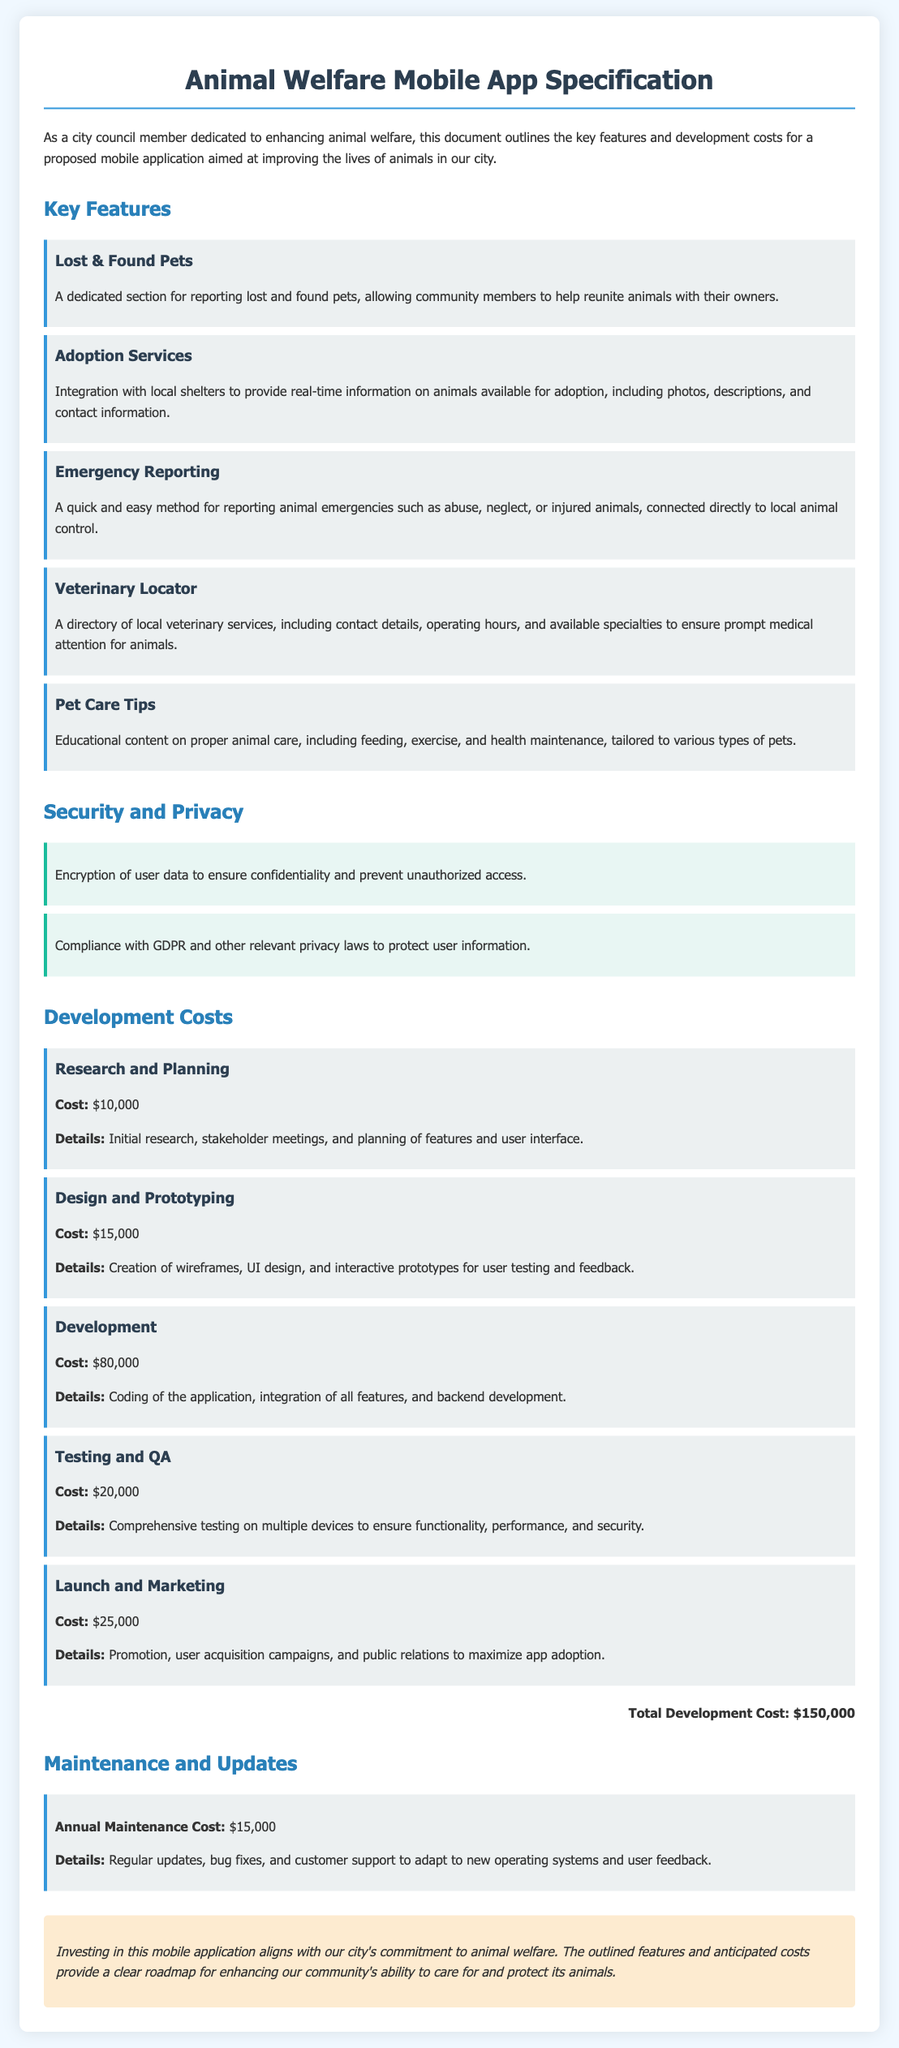what is the cost for research and planning? The cost for research and planning is specifically outlined in the document as $10,000.
Answer: $10,000 what feature allows users to report emergencies? The feature that allows users to report emergencies is labeled as "Emergency Reporting" in the document.
Answer: Emergency Reporting how much is the total development cost? The total development cost is prominently stated as $150,000 in the document.
Answer: $150,000 what is included in the veterinary locator feature? The veterinary locator feature includes a directory of local veterinary services with contact details, operating hours, and specialties.
Answer: Directory of local veterinary services what is the annual maintenance cost? The annual maintenance cost is detailed in the document as being $15,000.
Answer: $15,000 which law does the app comply with for user data protection? The app complies with GDPR among other relevant privacy laws for user data protection.
Answer: GDPR what is a key purpose of the adoption services feature? A key purpose of the adoption services feature is to provide real-time information on animals available for adoption.
Answer: Real-time information on animals available for adoption how much is allocated for testing and QA? The allocation for testing and QA is specified as $20,000.
Answer: $20,000 which aspect of the application focuses on educating pet owners? The aspect of the application that focuses on educating pet owners is labeled as "Pet Care Tips".
Answer: Pet Care Tips 